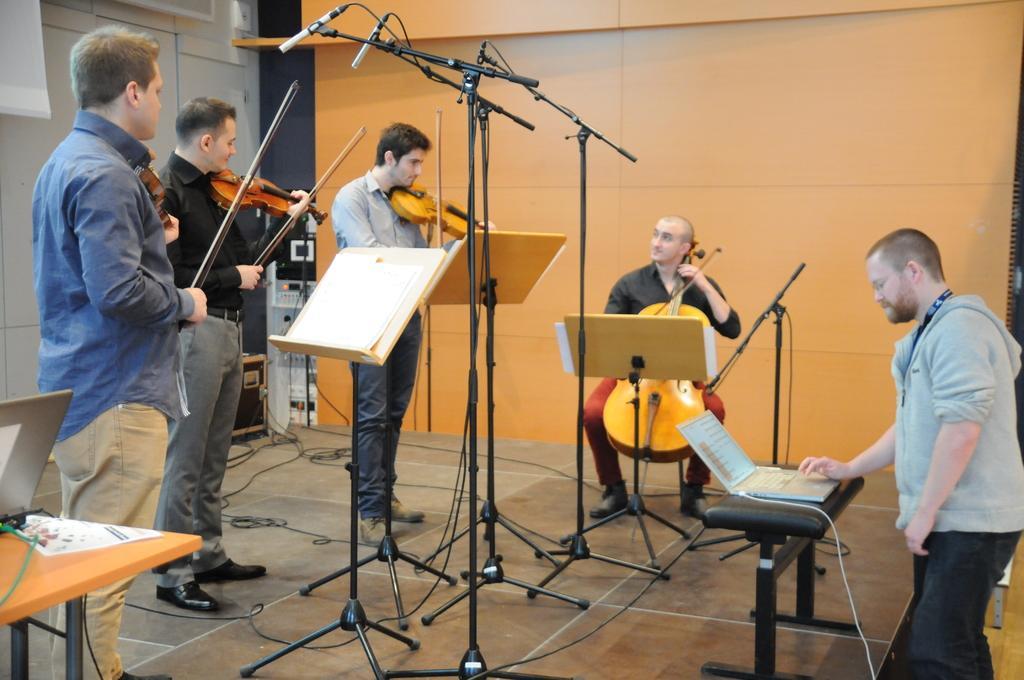Describe this image in one or two sentences. This picture describes about group of people, few people are playing violins, in front of them we can see few microphones and papers on the stands, on the right side of the image we can see a man, in front of him we can see a laptop, in the background we can see few musical instruments and cables. 